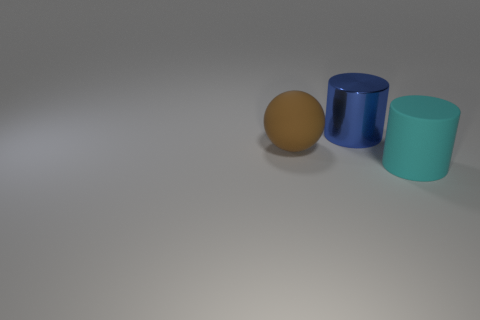There is a big rubber thing that is in front of the big brown rubber ball; what shape is it?
Ensure brevity in your answer.  Cylinder. What is the color of the big matte ball?
Ensure brevity in your answer.  Brown. What number of big blue things are behind the cylinder to the left of the big cyan thing?
Your answer should be very brief. 0. Do the rubber cylinder and the rubber thing left of the cyan matte object have the same size?
Your answer should be compact. Yes. Is the size of the brown sphere the same as the cyan rubber thing?
Your answer should be compact. Yes. Are there any other things that have the same size as the blue thing?
Your response must be concise. Yes. What is the material of the cylinder in front of the blue shiny cylinder?
Offer a very short reply. Rubber. What color is the big sphere that is the same material as the large cyan object?
Offer a very short reply. Brown. How many rubber objects are either large brown balls or big objects?
Make the answer very short. 2. What is the shape of the cyan rubber thing that is the same size as the blue shiny cylinder?
Offer a very short reply. Cylinder. 